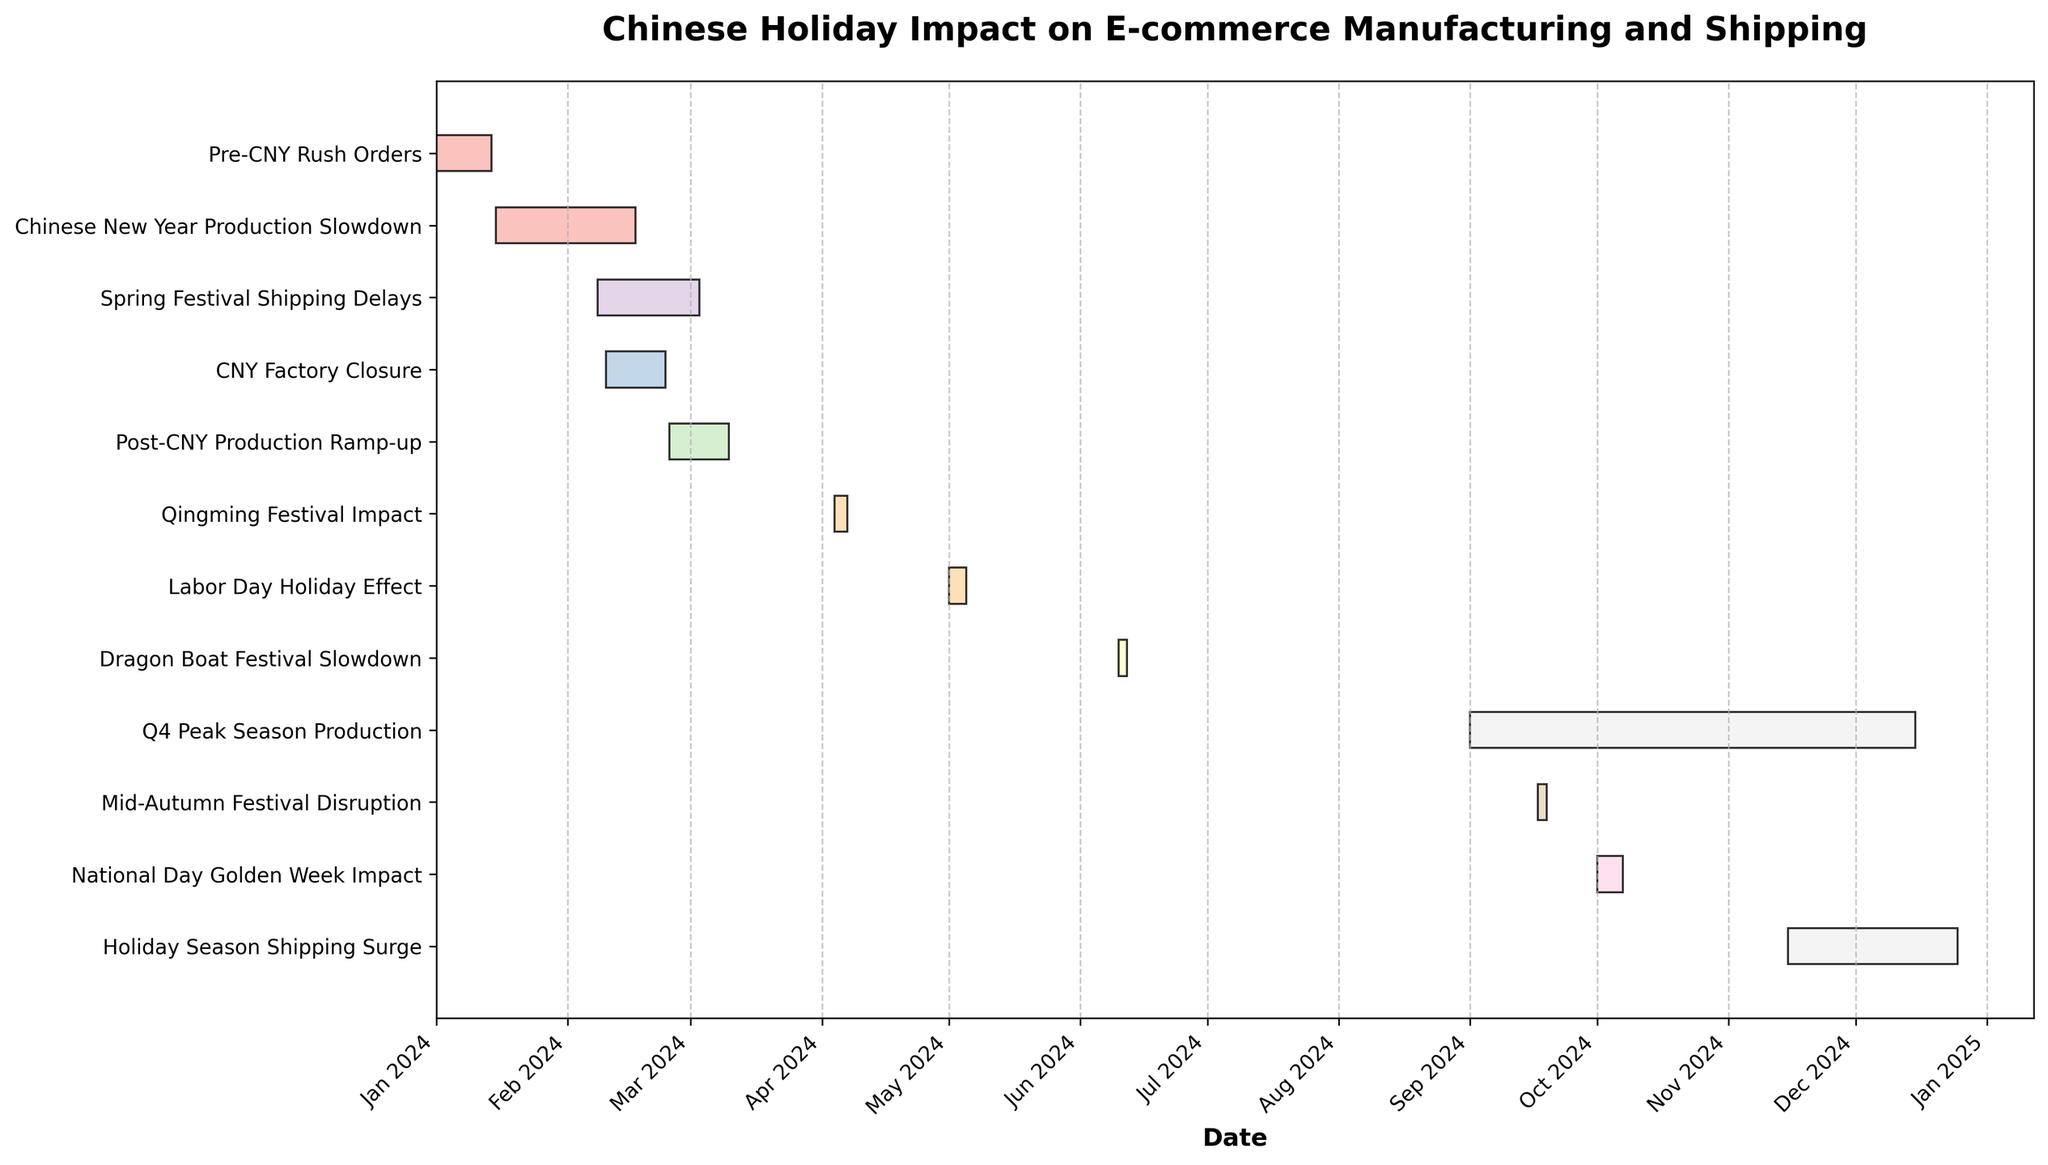What is the title of the figure? The title of the figure is positioned at the top and reads "Chinese Holiday Impact on E-commerce Manufacturing and Shipping".
Answer: Chinese Holiday Impact on E-commerce Manufacturing and Shipping How long is the "Chinese New Year Production Slowdown" period? To find the duration of the Chinese New Year Production Slowdown, calculate the difference between its start date (2024-01-15) and end date (2024-02-17). The time span is 33 days.
Answer: 33 days Which task covers the longest time period? By comparing the lengths of each task bar in the figure, the "Q4 Peak Season Production" has the longest duration, starting from 2024-09-01 and ending on 2024-12-15, lasting 106 days.
Answer: Q4 Peak Season Production When does the "Pre-CNY Rush Orders" task start and end? The start and end dates for "Pre-CNY Rush Orders" are directly labeled in the figure, starting on 2024-01-01 and ending on 2024-01-14.
Answer: 2024-01-01 to 2024-01-14 Which holiday overlaps with the "Spring Festival Shipping Delays"? The "Spring Festival Shipping Delays" overlap with the "CNY Factory Closure" as they have overlapping date ranges in the figure. The former lasts from 2024-02-08 to 2024-03-03, while the latter is from 2024-02-10 to 2024-02-24.
Answer: CNY Factory Closure What is the duration of the "Labor Day Holiday Effect"? The duration is calculated by subtracting the start date (2024-05-01) from the end date (2024-05-05). This gives a period of 4 days.
Answer: 4 days How many tasks are impacted by holidays in the first quarter? By examining the start and end dates, tasks impacted in Q1 include "Chinese New Year Production Slowdown", "Pre-CNY Rush Orders", "CNY Factory Closure", "Post-CNY Production Ramp-up", and "Spring Festival Shipping Delays".
Answer: 5 tasks Which task ends last within the year 2024? By checking the end dates of all tasks, the "Holiday Season Shipping Surge" ends last on 2024-12-25.
Answer: Holiday Season Shipping Surge Compare the durations of "Dragon Boat Festival Slowdown" and "Mid-Autumn Festival Disruption". Which is longer? The "Dragon Boat Festival Slowdown" lasts for 3 days (2024-06-10 to 2024-06-12), while the "Mid-Autumn Festival Disruption" also lasts for 3 days (2024-09-17 to 2024-09-19). Both events have the same duration.
Answer: Both are 3 days How does the "National Day Golden Week Impact" relate to other tasks in October? The "National Day Golden Week Impact" is the only task listed in October, from 2024-10-01 to 2024-10-07. It does not overlap with any other task in that month.
Answer: Sole task in October 